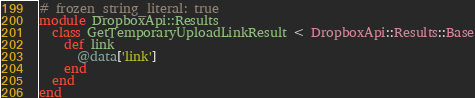<code> <loc_0><loc_0><loc_500><loc_500><_Ruby_># frozen_string_literal: true
module DropboxApi::Results
  class GetTemporaryUploadLinkResult < DropboxApi::Results::Base
    def link
      @data['link']
    end
  end
end
</code> 